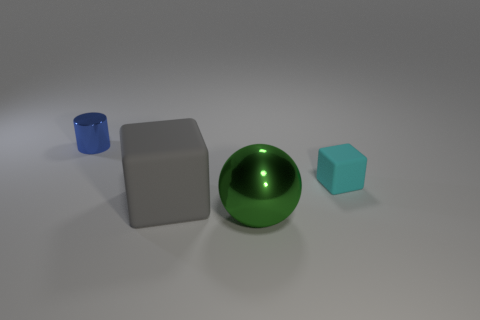The small thing that is right of the rubber cube to the left of the small cyan rubber object is made of what material?
Your answer should be compact. Rubber. There is a rubber object that is left of the tiny object right of the rubber block left of the cyan rubber cube; what is its size?
Offer a terse response. Large. Is the cyan matte object the same size as the gray thing?
Provide a succinct answer. No. Do the object on the right side of the green shiny object and the matte object to the left of the small rubber object have the same shape?
Give a very brief answer. Yes. There is a metal thing to the left of the green metal ball; is there a shiny object that is on the right side of it?
Offer a terse response. Yes. Is there a large gray cube?
Your answer should be very brief. Yes. What number of blue cylinders have the same size as the cyan rubber cube?
Keep it short and to the point. 1. How many objects are to the right of the big cube and in front of the tiny rubber cube?
Offer a terse response. 1. Does the cube to the left of the green sphere have the same size as the green shiny object?
Ensure brevity in your answer.  Yes. Is there a large matte object of the same color as the big ball?
Offer a terse response. No. 